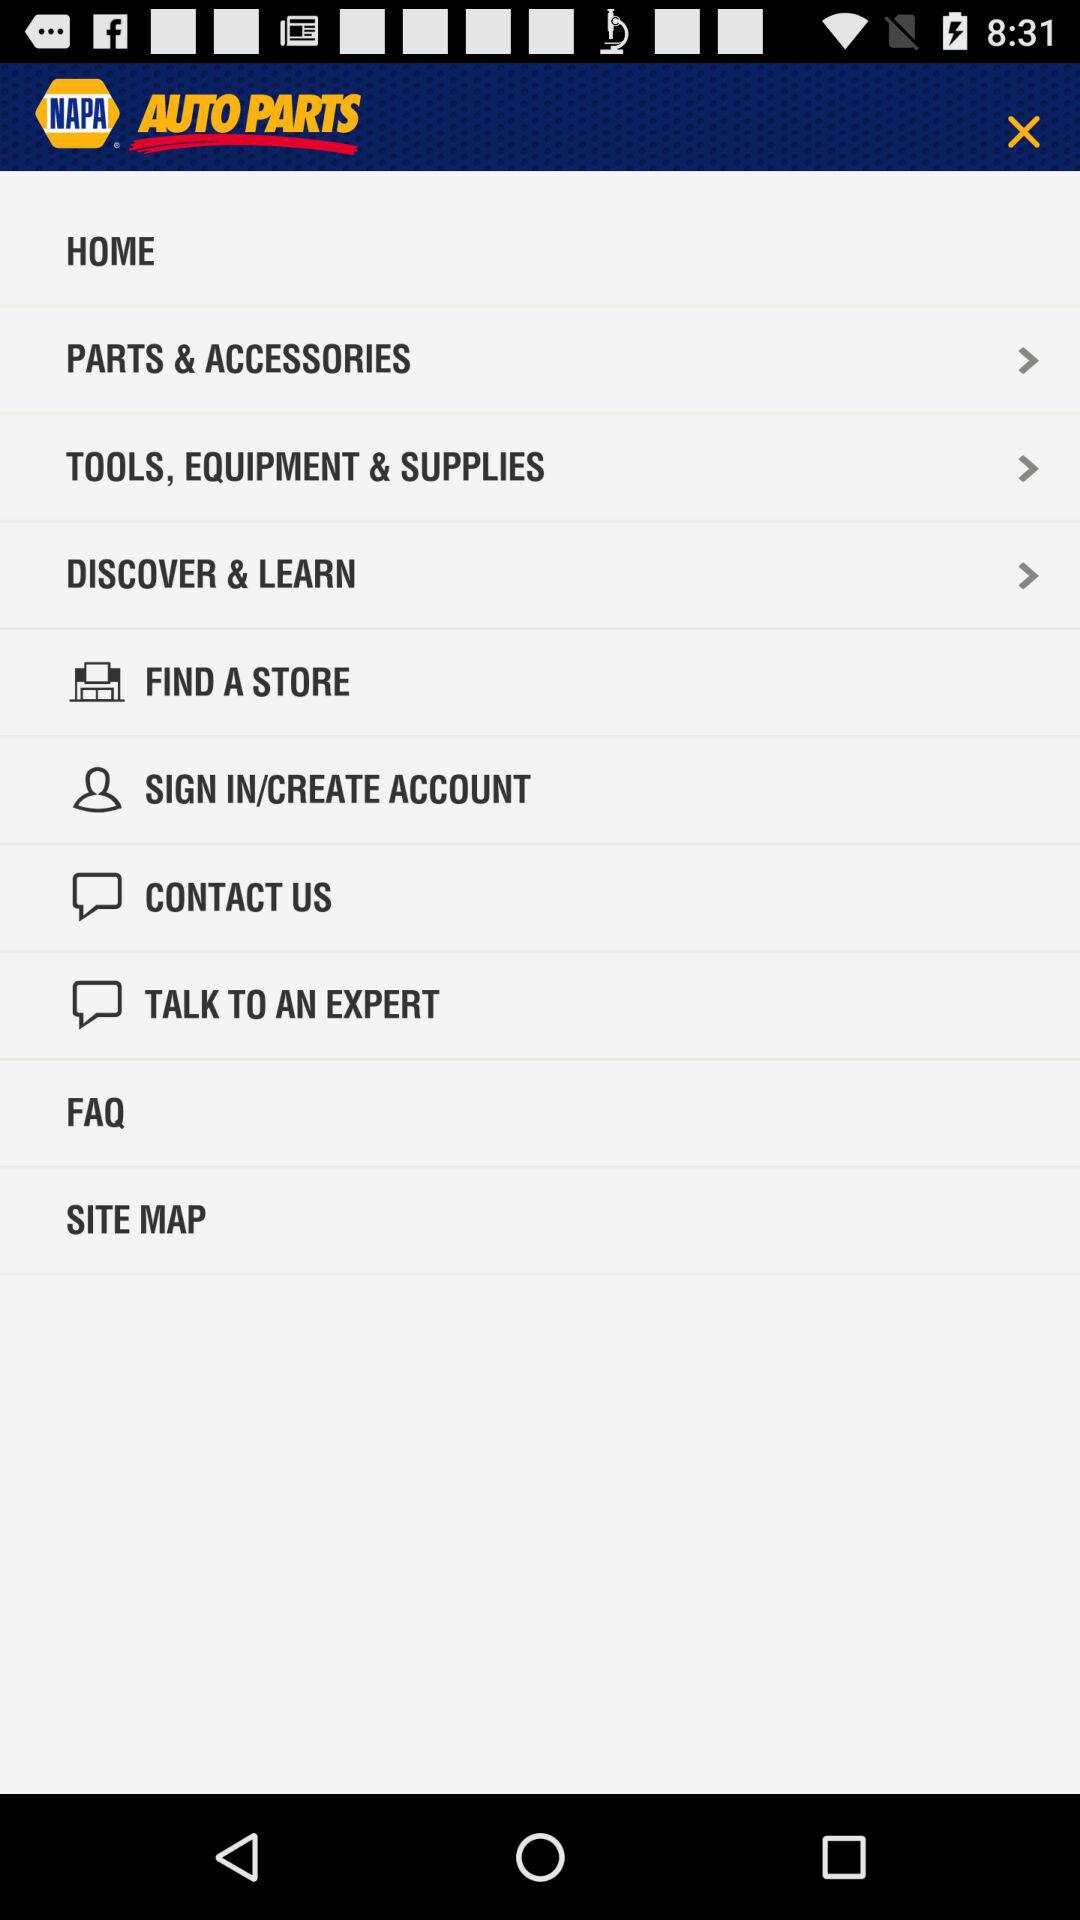What is the name of the application? The name of the application is "NAPA AUTO PARTS". 